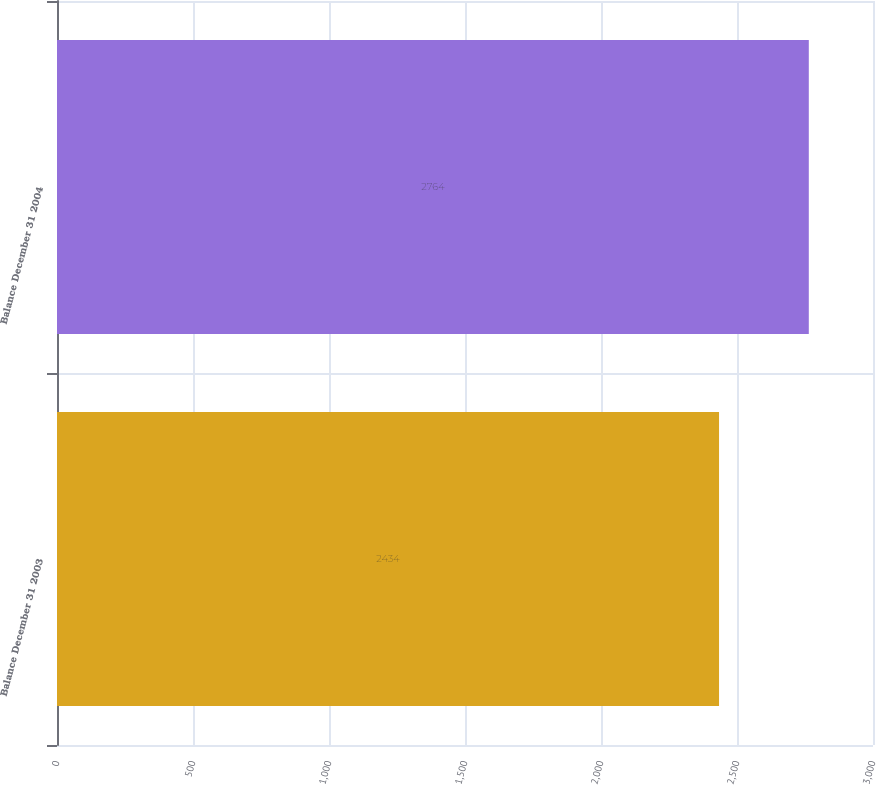Convert chart to OTSL. <chart><loc_0><loc_0><loc_500><loc_500><bar_chart><fcel>Balance December 31 2003<fcel>Balance December 31 2004<nl><fcel>2434<fcel>2764<nl></chart> 